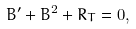Convert formula to latex. <formula><loc_0><loc_0><loc_500><loc_500>B ^ { \prime } + B ^ { 2 } + R _ { T } = 0 ,</formula> 